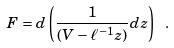Convert formula to latex. <formula><loc_0><loc_0><loc_500><loc_500>F = d \left ( { \frac { 1 } { ( V - \ell ^ { - 1 } z ) } } d z \right ) \ .</formula> 